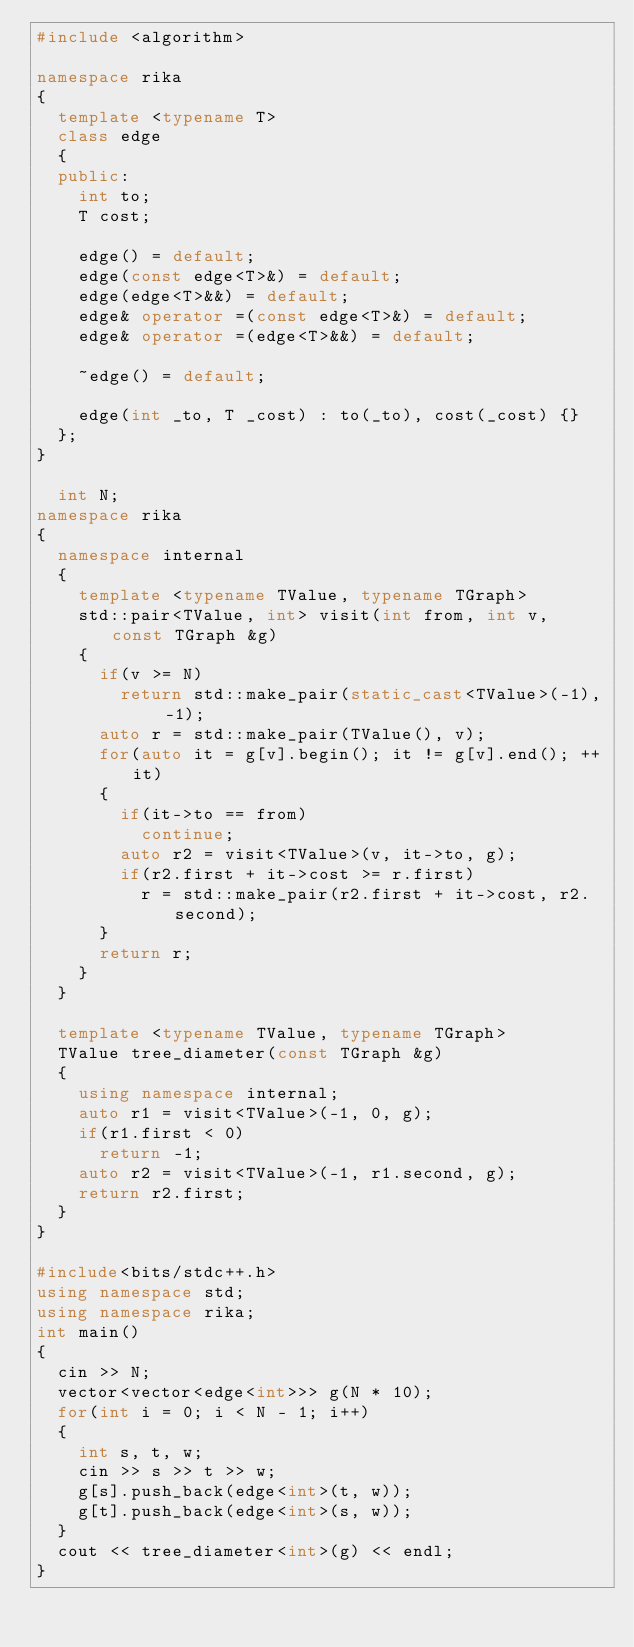<code> <loc_0><loc_0><loc_500><loc_500><_C++_>#include <algorithm>

namespace rika
{
  template <typename T>
  class edge
  {
  public:
    int to;
    T cost;
    
    edge() = default;
    edge(const edge<T>&) = default;
    edge(edge<T>&&) = default;
    edge& operator =(const edge<T>&) = default;
    edge& operator =(edge<T>&&) = default;

    ~edge() = default;

    edge(int _to, T _cost) : to(_to), cost(_cost) {}
  };
}

  int N;
namespace rika
{
  namespace internal
  {
    template <typename TValue, typename TGraph>
    std::pair<TValue, int> visit(int from, int v, const TGraph &g)
    {
      if(v >= N)
        return std::make_pair(static_cast<TValue>(-1), -1);
      auto r = std::make_pair(TValue(), v);
      for(auto it = g[v].begin(); it != g[v].end(); ++it)
      {
        if(it->to == from)
          continue;
        auto r2 = visit<TValue>(v, it->to, g);
        if(r2.first + it->cost >= r.first)
          r = std::make_pair(r2.first + it->cost, r2.second);
      }
      return r;
    }
  }

  template <typename TValue, typename TGraph>
  TValue tree_diameter(const TGraph &g)
  {
    using namespace internal;
    auto r1 = visit<TValue>(-1, 0, g);
    if(r1.first < 0)
      return -1;
    auto r2 = visit<TValue>(-1, r1.second, g);
    return r2.first;
  }
}

#include<bits/stdc++.h>
using namespace std;
using namespace rika;
int main()
{
  cin >> N;
  vector<vector<edge<int>>> g(N * 10);
  for(int i = 0; i < N - 1; i++)
  {
    int s, t, w;
    cin >> s >> t >> w;
    g[s].push_back(edge<int>(t, w));
    g[t].push_back(edge<int>(s, w));
  }
  cout << tree_diameter<int>(g) << endl;
}</code> 